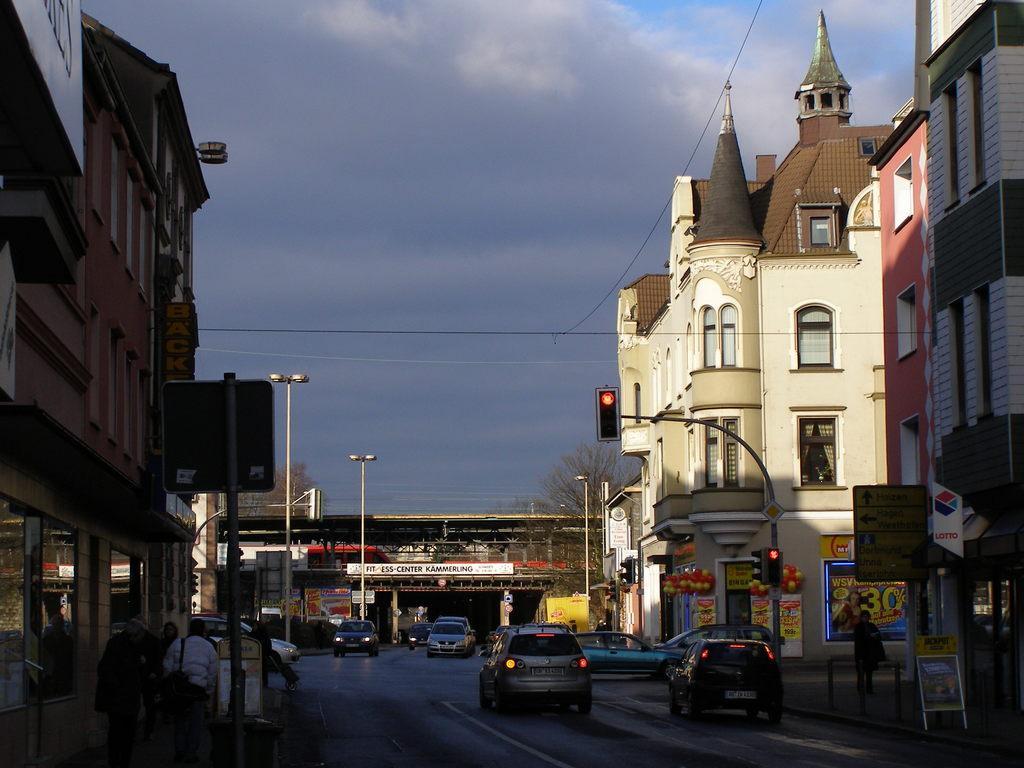Describe this image in one or two sentences. In this picture I can see the vehicles on the road. I can see the buildings. I can see traffic lights. I can see a few people on the walkway. I can see pole lights. I can see trees. I can see the bridge. I can see clouds in the sky. I can see electric wires. 